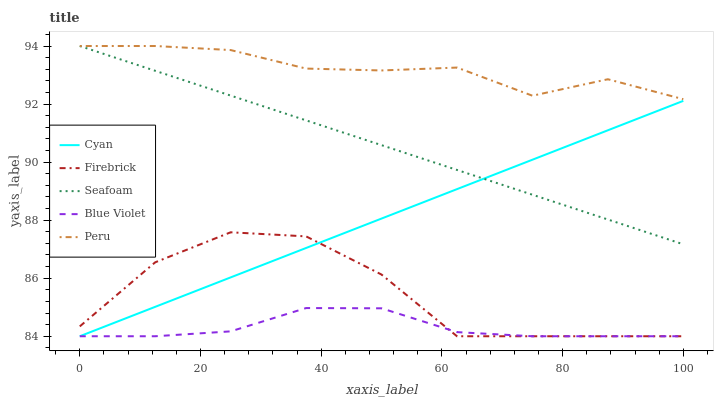Does Blue Violet have the minimum area under the curve?
Answer yes or no. Yes. Does Peru have the maximum area under the curve?
Answer yes or no. Yes. Does Cyan have the minimum area under the curve?
Answer yes or no. No. Does Cyan have the maximum area under the curve?
Answer yes or no. No. Is Cyan the smoothest?
Answer yes or no. Yes. Is Firebrick the roughest?
Answer yes or no. Yes. Is Firebrick the smoothest?
Answer yes or no. No. Is Cyan the roughest?
Answer yes or no. No. Does Cyan have the lowest value?
Answer yes or no. Yes. Does Seafoam have the lowest value?
Answer yes or no. No. Does Seafoam have the highest value?
Answer yes or no. Yes. Does Cyan have the highest value?
Answer yes or no. No. Is Cyan less than Peru?
Answer yes or no. Yes. Is Seafoam greater than Blue Violet?
Answer yes or no. Yes. Does Firebrick intersect Blue Violet?
Answer yes or no. Yes. Is Firebrick less than Blue Violet?
Answer yes or no. No. Is Firebrick greater than Blue Violet?
Answer yes or no. No. Does Cyan intersect Peru?
Answer yes or no. No. 